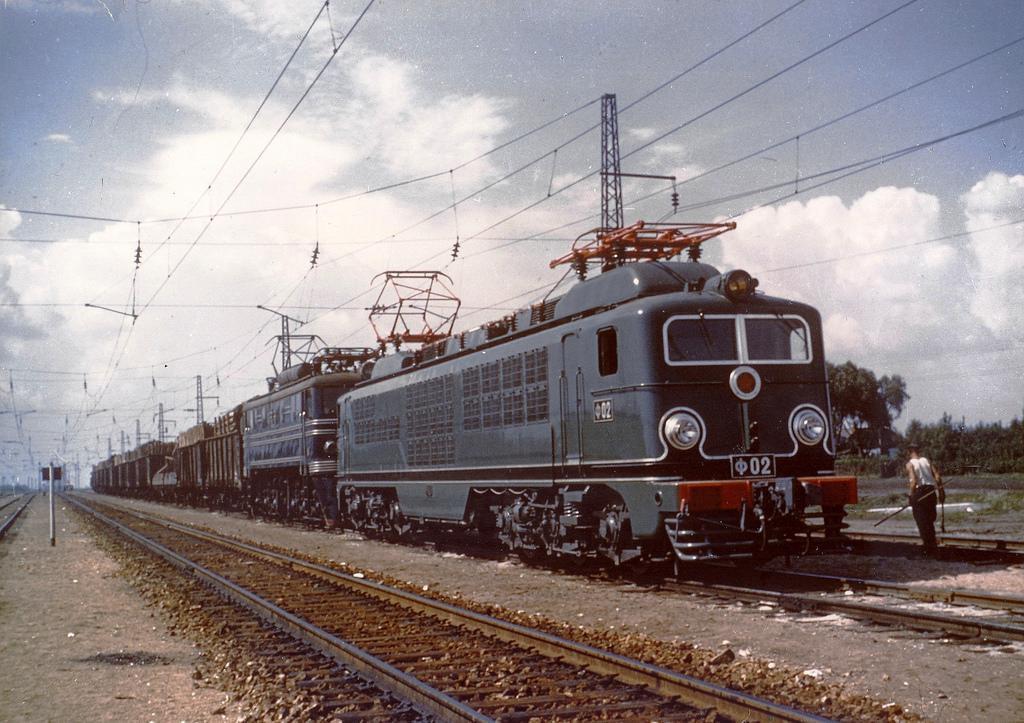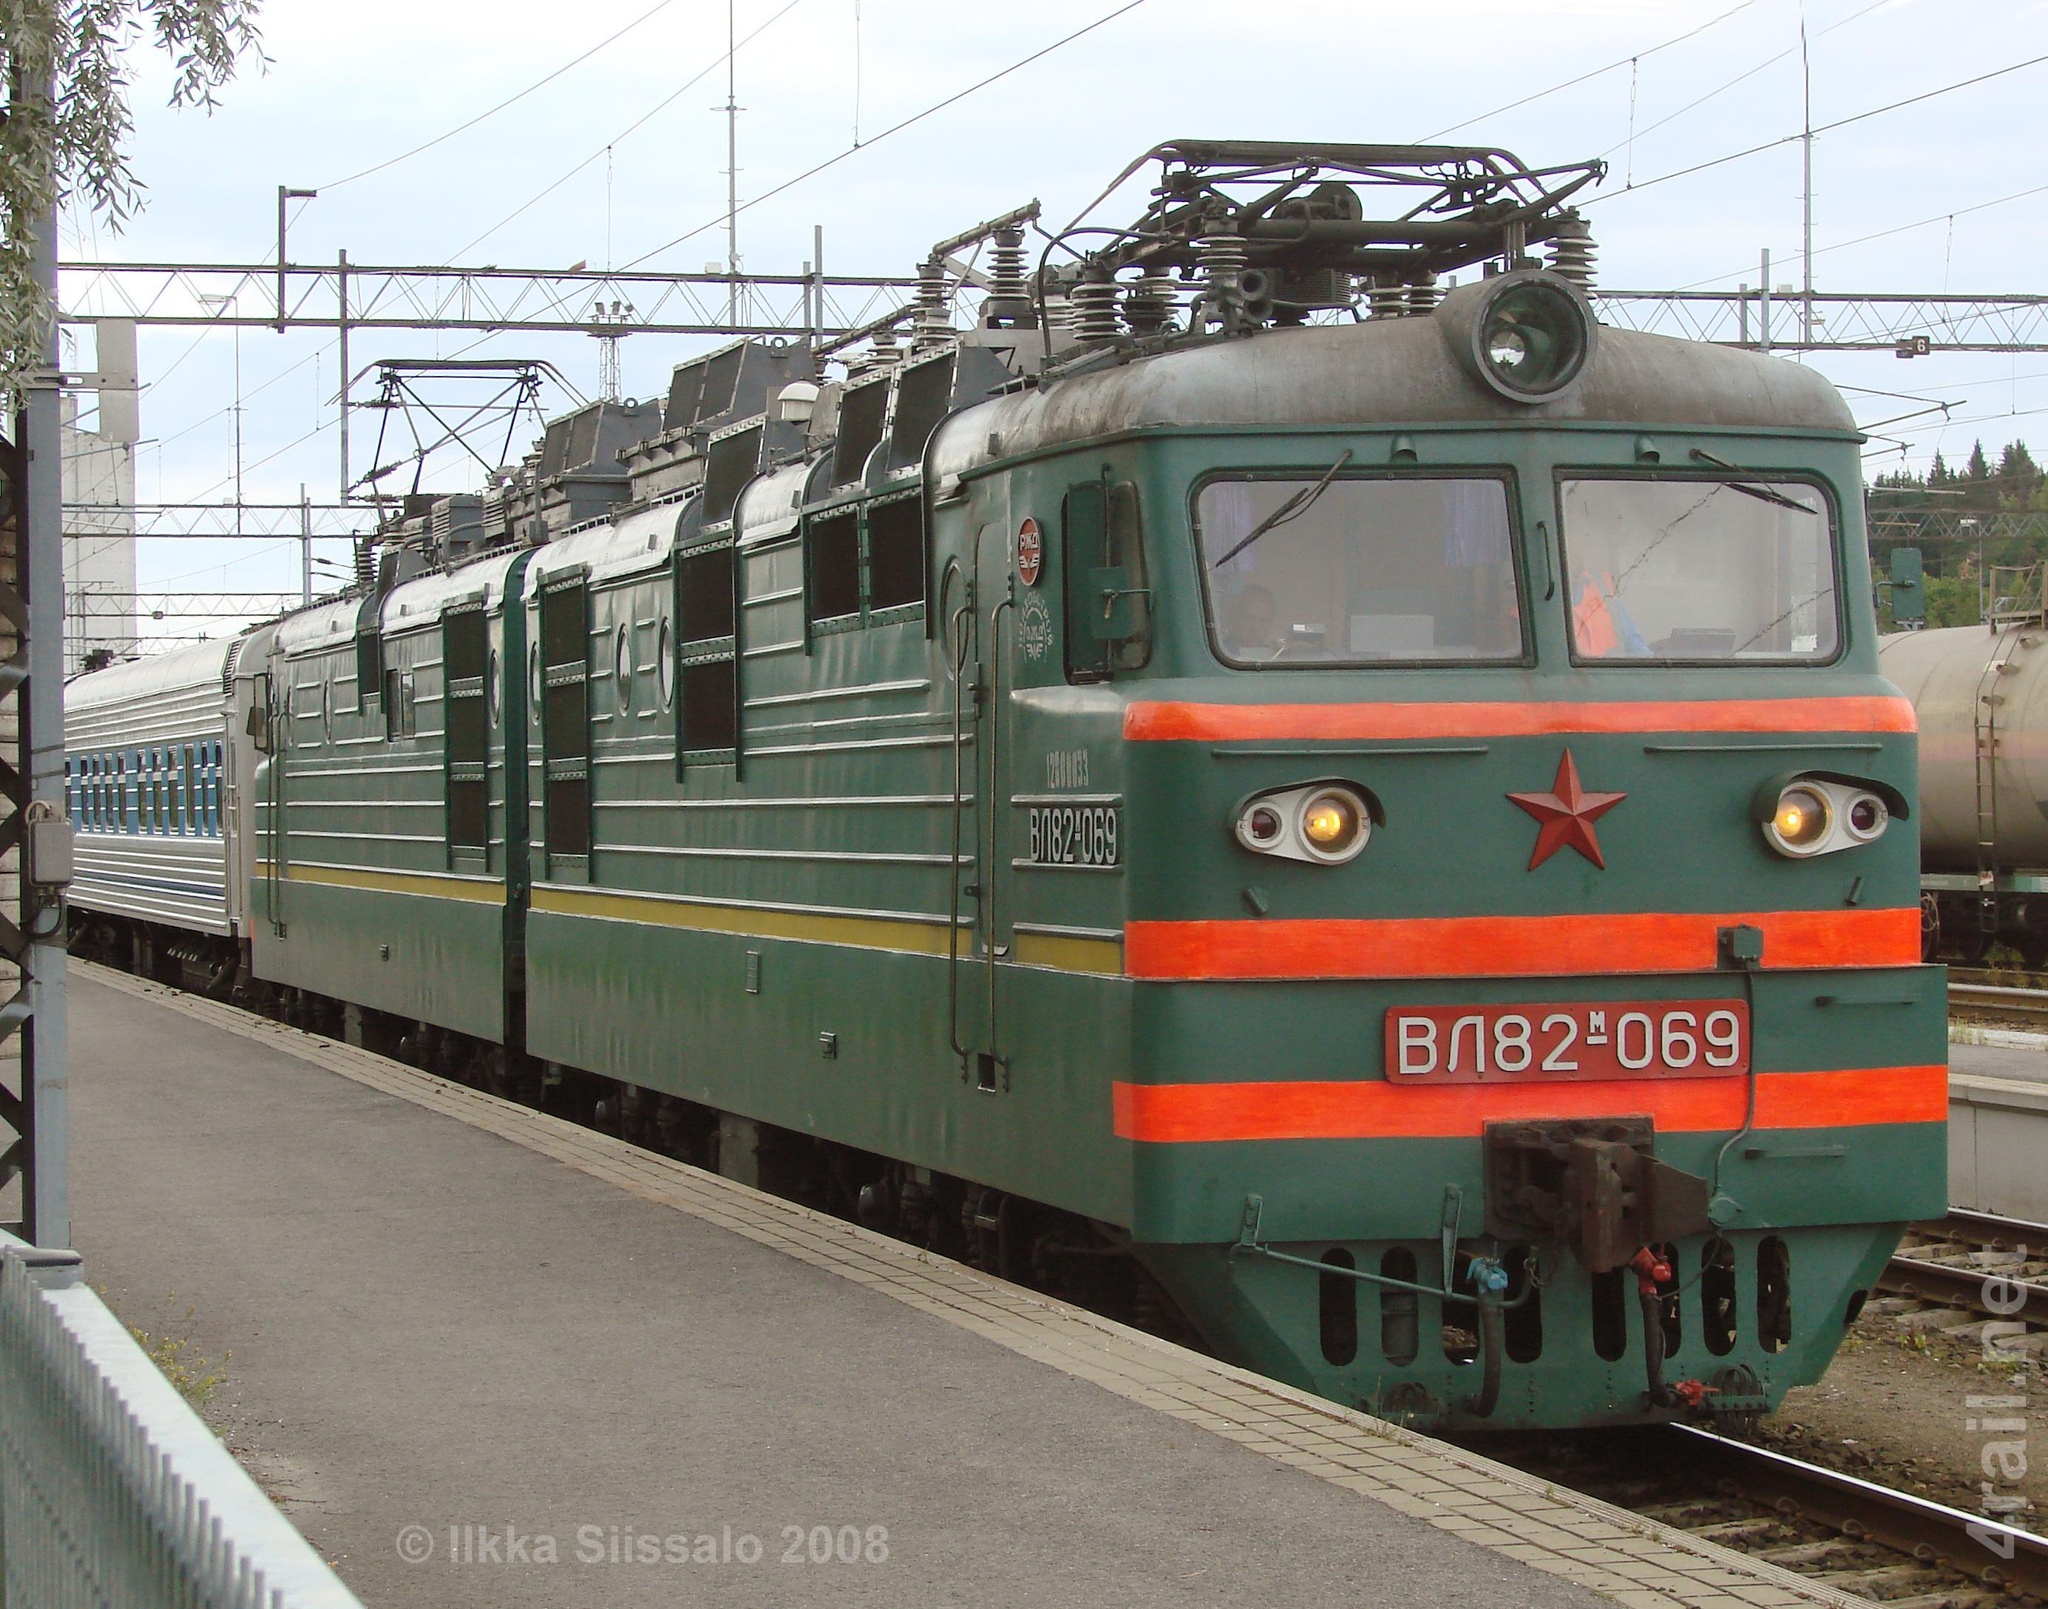The first image is the image on the left, the second image is the image on the right. Considering the images on both sides, is "All trains have a reddish front, and no image shows the front of more than one train." valid? Answer yes or no. No. The first image is the image on the left, the second image is the image on the right. Given the left and right images, does the statement "All trains are facing the same direction." hold true? Answer yes or no. Yes. 